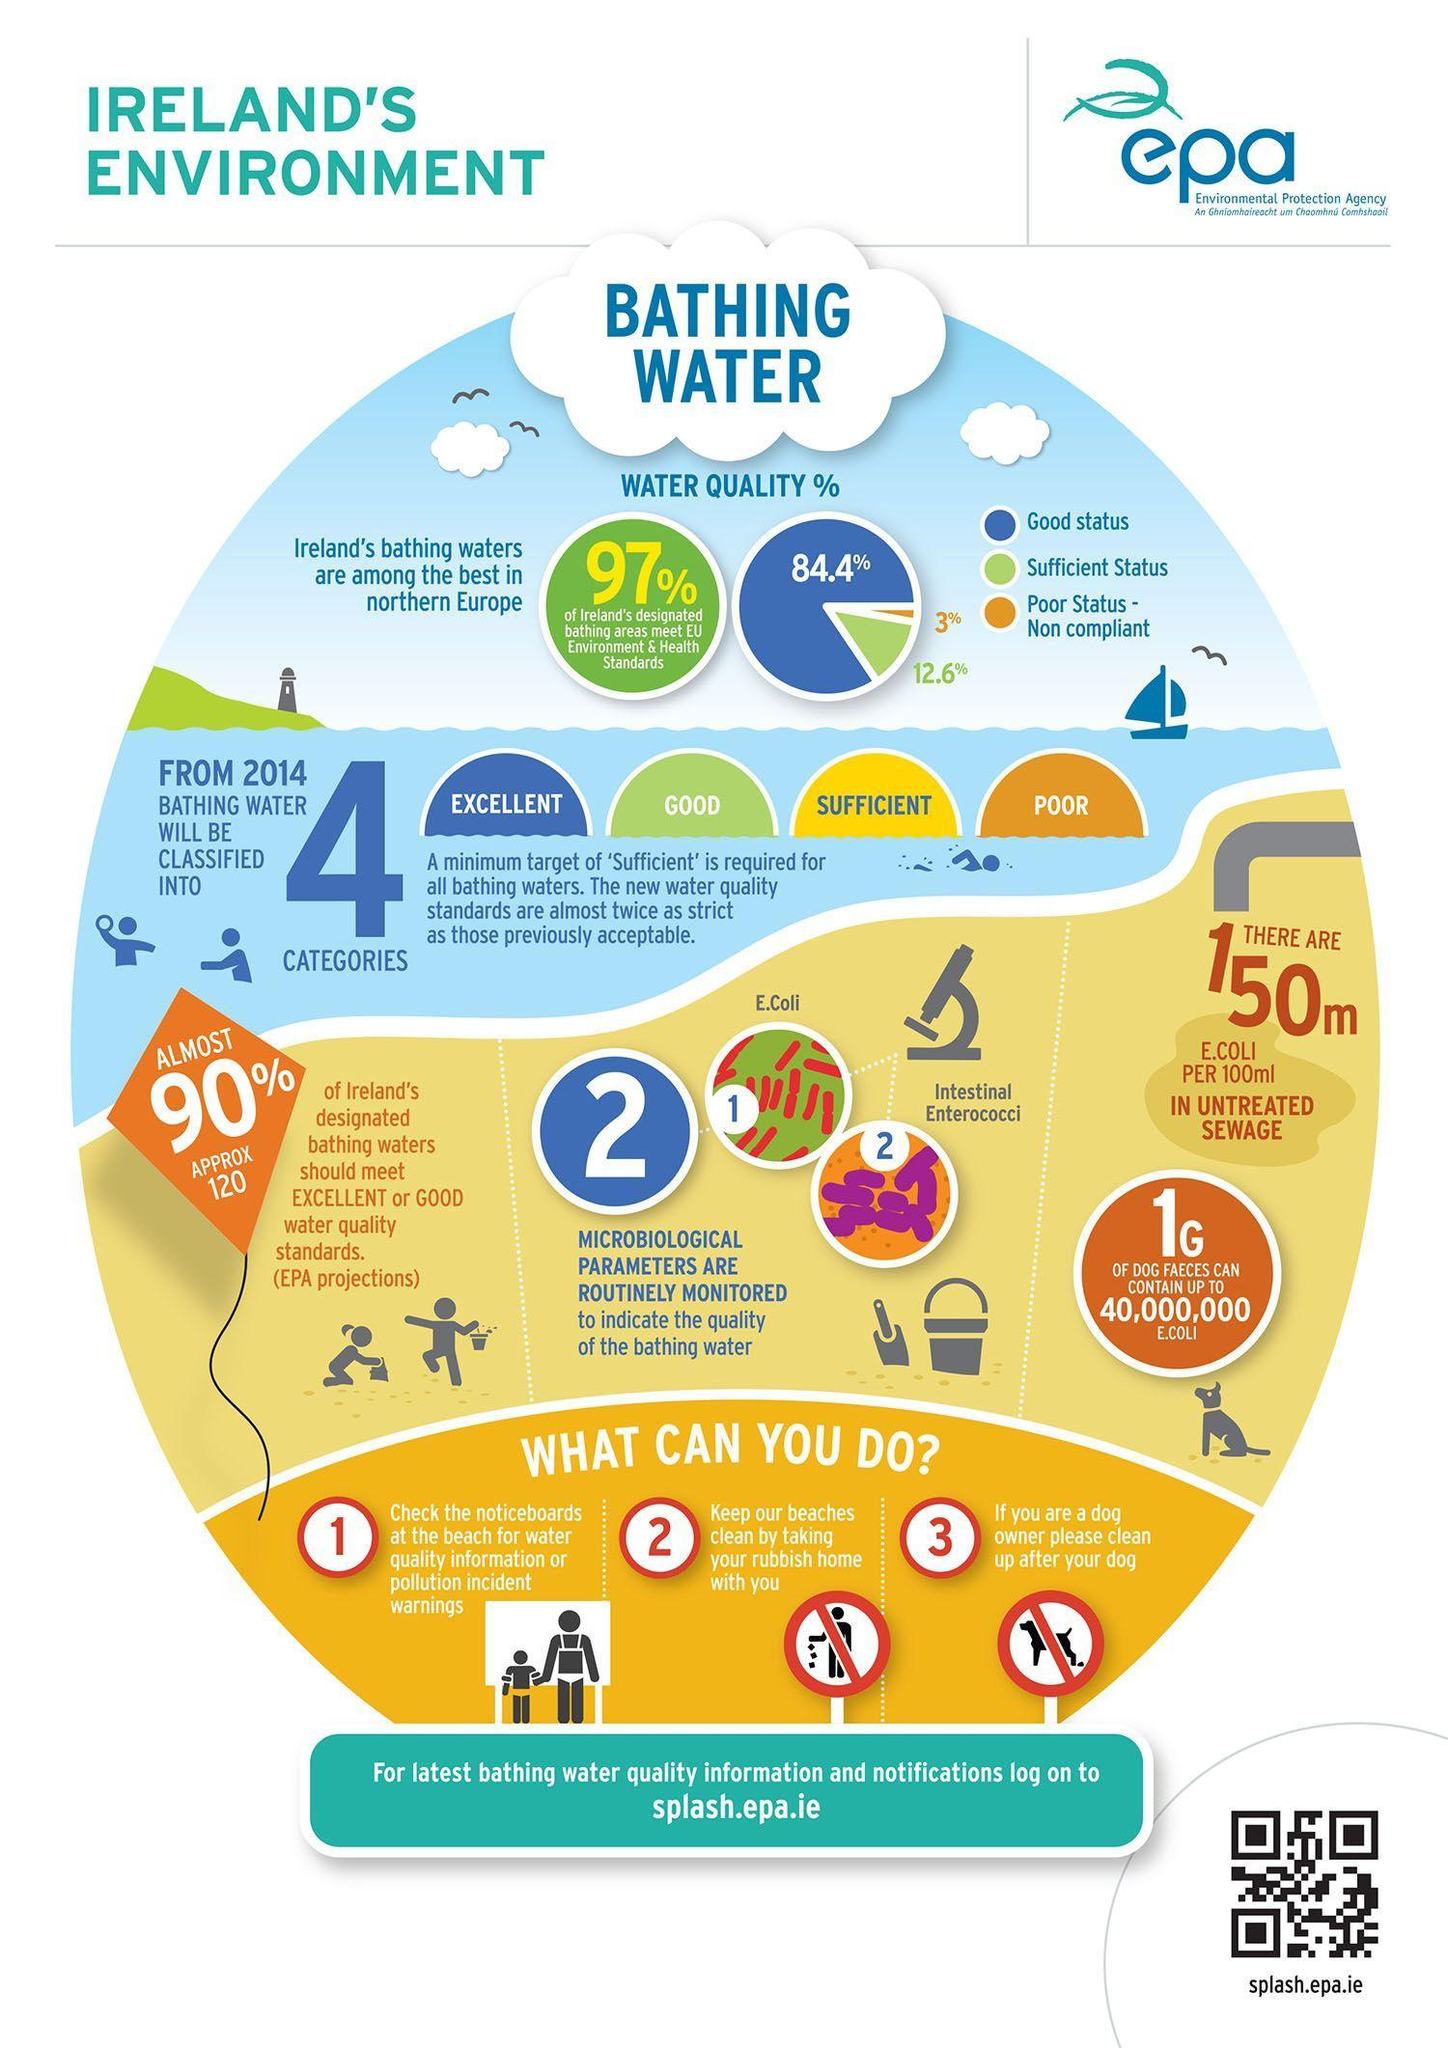What percent of the Ireland's bathing waters are of good water quality standard?
Answer the question with a short phrase. 84.4% What is the amount of E.Coli per 100ml in untreated sewage? 150m What are the two microbiological parameters routinely monitored to indicate the quality of the bathing water? E.Coli, Intestinal Enterococci What percent of the Ireland's bathing waters are of poor water quality standard? 3% 